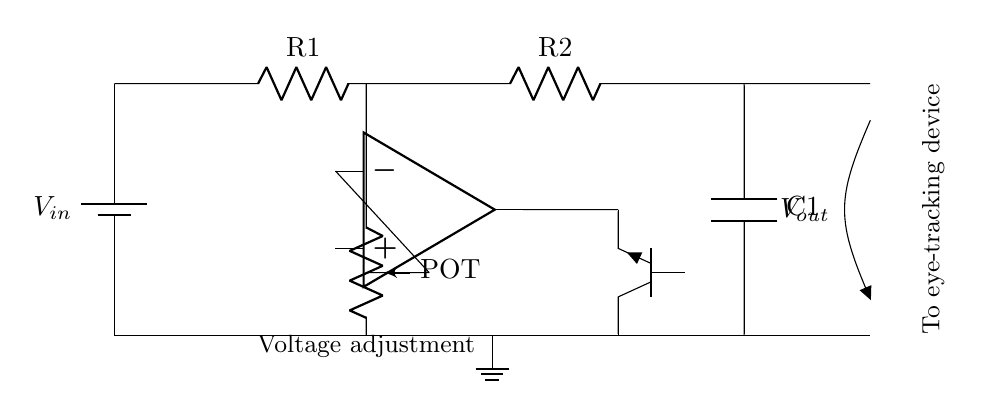What is the type of the variable voltage regulator component used? The circuit includes a potentiometer for voltage adjustment indicating it is a variable voltage regulator. A potentiometer allows variable resistance, which helps control the output voltage.
Answer: potentiometer What connects the operational amplifier to the transistor? The operational amplifier output connects to the base of the transistor. This connection is crucial because it allows the op-amp to control the transistor's switching based on its output voltage levels.
Answer: base of the transistor How many resistors are present in the circuit? The circuit diagram shows two resistors labeled R1 and R2, connected in series. Counting these provides the total number of resistive components.
Answer: two What is the purpose of the capacitor in the circuit? The capacitor, C1, serves to smooth out the output voltage, reducing noise and providing stability to the supply for the eye-tracking device. This helps in filtering any fluctuations in the voltage output.
Answer: to smooth output voltage What is the voltage input to the circuit? The input voltage, denoted as Vin in the battery label, is the voltage provided to the circuit. It can be referred to but not specified in the diagram; generally, this is where we look for voltage specifications in similar circuits.
Answer: Vin Which component indicates the output voltage? The output voltage is indicated by Vout, which is the point labeled in the circuit where the regulated voltage is delivered to the eye-tracking device. This is crucial for ensuring the correct voltage level for the device's operation.
Answer: Vout 